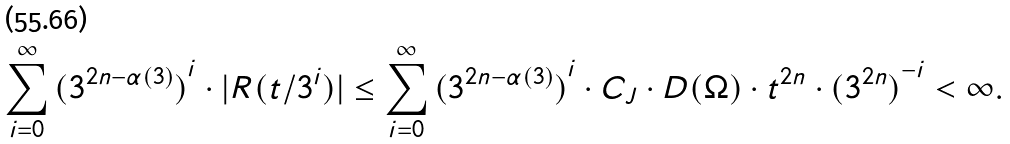Convert formula to latex. <formula><loc_0><loc_0><loc_500><loc_500>\sum _ { i = 0 } ^ { \infty } { ( 3 ^ { 2 n - \alpha ( 3 ) } ) } ^ { i } \cdot | R ( t / 3 ^ { i } ) | \leq \sum _ { i = 0 } ^ { \infty } { ( 3 ^ { 2 n - \alpha ( 3 ) } ) } ^ { i } \cdot C _ { J } \cdot D ( \Omega ) \cdot t ^ { 2 n } \cdot { ( 3 ^ { 2 n } ) } ^ { - i } < \infty .</formula> 